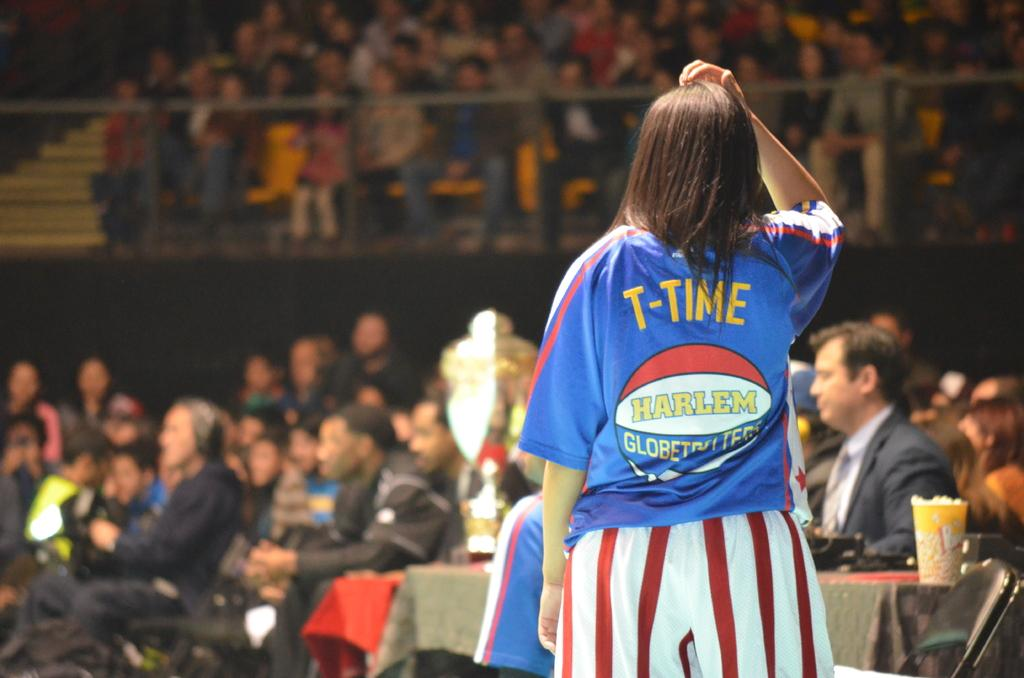<image>
Create a compact narrative representing the image presented. Woman wearing a shirt that says T-Time on it. 